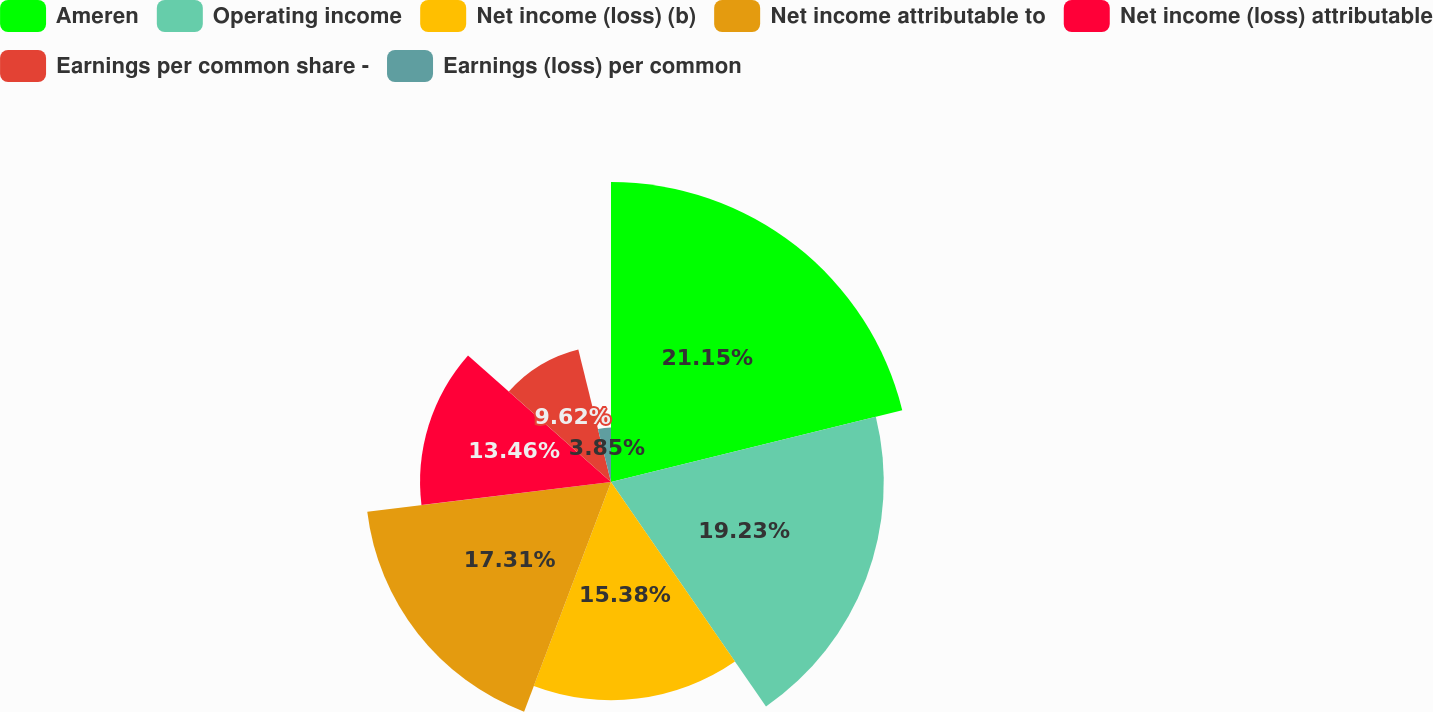<chart> <loc_0><loc_0><loc_500><loc_500><pie_chart><fcel>Ameren<fcel>Operating income<fcel>Net income (loss) (b)<fcel>Net income attributable to<fcel>Net income (loss) attributable<fcel>Earnings per common share -<fcel>Earnings (loss) per common<nl><fcel>21.15%<fcel>19.23%<fcel>15.38%<fcel>17.31%<fcel>13.46%<fcel>9.62%<fcel>3.85%<nl></chart> 